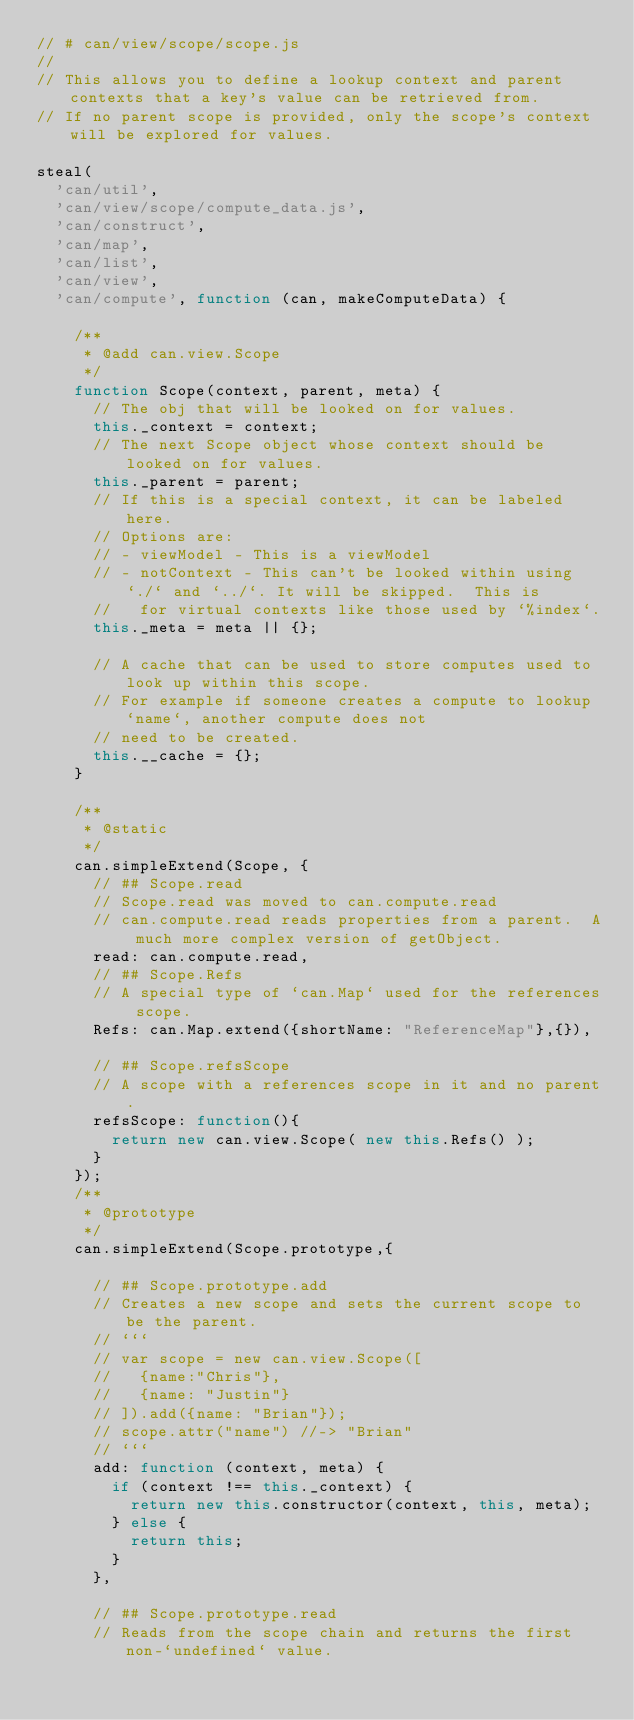Convert code to text. <code><loc_0><loc_0><loc_500><loc_500><_JavaScript_>// # can/view/scope/scope.js
//
// This allows you to define a lookup context and parent contexts that a key's value can be retrieved from.
// If no parent scope is provided, only the scope's context will be explored for values.

steal(
	'can/util',
	'can/view/scope/compute_data.js',
	'can/construct',
	'can/map',
	'can/list',
	'can/view',
	'can/compute', function (can, makeComputeData) {

		/**
		 * @add can.view.Scope
		 */
		function Scope(context, parent, meta) {
			// The obj that will be looked on for values.
			this._context = context;
			// The next Scope object whose context should be looked on for values.
			this._parent = parent;
			// If this is a special context, it can be labeled here.
			// Options are:
			// - viewModel - This is a viewModel
			// - notContext - This can't be looked within using `./` and `../`. It will be skipped.  This is
			//   for virtual contexts like those used by `%index`.
			this._meta = meta || {};

			// A cache that can be used to store computes used to look up within this scope.
			// For example if someone creates a compute to lookup `name`, another compute does not
			// need to be created.
			this.__cache = {};
		}

		/**
		 * @static
		 */
		can.simpleExtend(Scope, {
			// ## Scope.read
			// Scope.read was moved to can.compute.read
			// can.compute.read reads properties from a parent.  A much more complex version of getObject.
			read: can.compute.read,
			// ## Scope.Refs
			// A special type of `can.Map` used for the references scope.
			Refs: can.Map.extend({shortName: "ReferenceMap"},{}),

			// ## Scope.refsScope
			// A scope with a references scope in it and no parent. 
			refsScope: function(){
				return new can.view.Scope( new this.Refs() );
			}
		});
		/**
		 * @prototype
		 */
		can.simpleExtend(Scope.prototype,{

			// ## Scope.prototype.add
			// Creates a new scope and sets the current scope to be the parent.
			// ```
			// var scope = new can.view.Scope([
			//   {name:"Chris"}, 
			//   {name: "Justin"}
			// ]).add({name: "Brian"});
			// scope.attr("name") //-> "Brian"
			// ```
			add: function (context, meta) {
				if (context !== this._context) {
					return new this.constructor(context, this, meta);
				} else {
					return this;
				}
			},

			// ## Scope.prototype.read
			// Reads from the scope chain and returns the first non-`undefined` value.</code> 